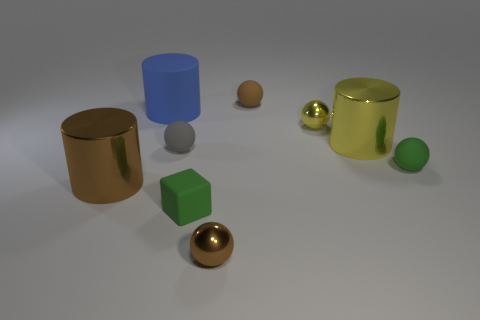There is a tiny shiny thing that is behind the large yellow metallic thing; what shape is it? sphere 